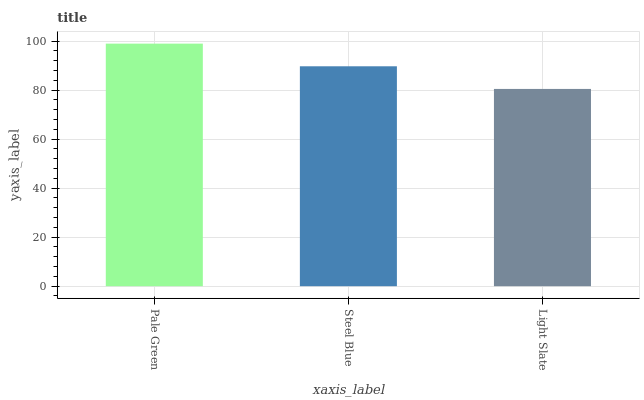Is Light Slate the minimum?
Answer yes or no. Yes. Is Pale Green the maximum?
Answer yes or no. Yes. Is Steel Blue the minimum?
Answer yes or no. No. Is Steel Blue the maximum?
Answer yes or no. No. Is Pale Green greater than Steel Blue?
Answer yes or no. Yes. Is Steel Blue less than Pale Green?
Answer yes or no. Yes. Is Steel Blue greater than Pale Green?
Answer yes or no. No. Is Pale Green less than Steel Blue?
Answer yes or no. No. Is Steel Blue the high median?
Answer yes or no. Yes. Is Steel Blue the low median?
Answer yes or no. Yes. Is Pale Green the high median?
Answer yes or no. No. Is Pale Green the low median?
Answer yes or no. No. 